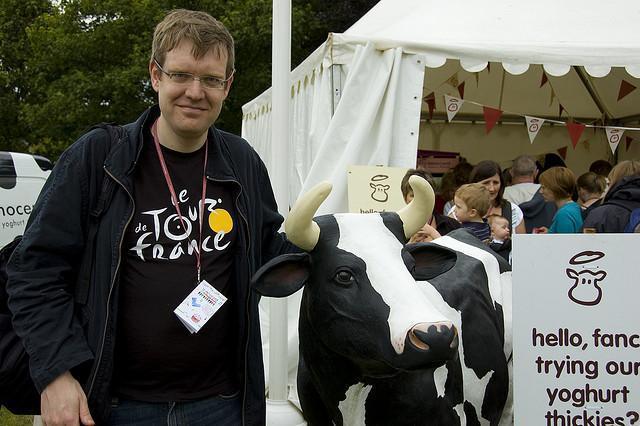What type of industry is being represented?
Make your selection from the four choices given to correctly answer the question.
Options: Dairy, clothing, gun, oil. Dairy. 